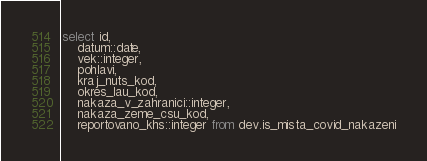<code> <loc_0><loc_0><loc_500><loc_500><_SQL_>select id,
	datum::date,
	vek::integer,
	pohlavi,
	kraj_nuts_kod,
	okres_lau_kod,
	nakaza_v_zahranici::integer,
	nakaza_zeme_csu_kod,
	reportovano_khs::integer from dev.is_mista_covid_nakazeni</code> 